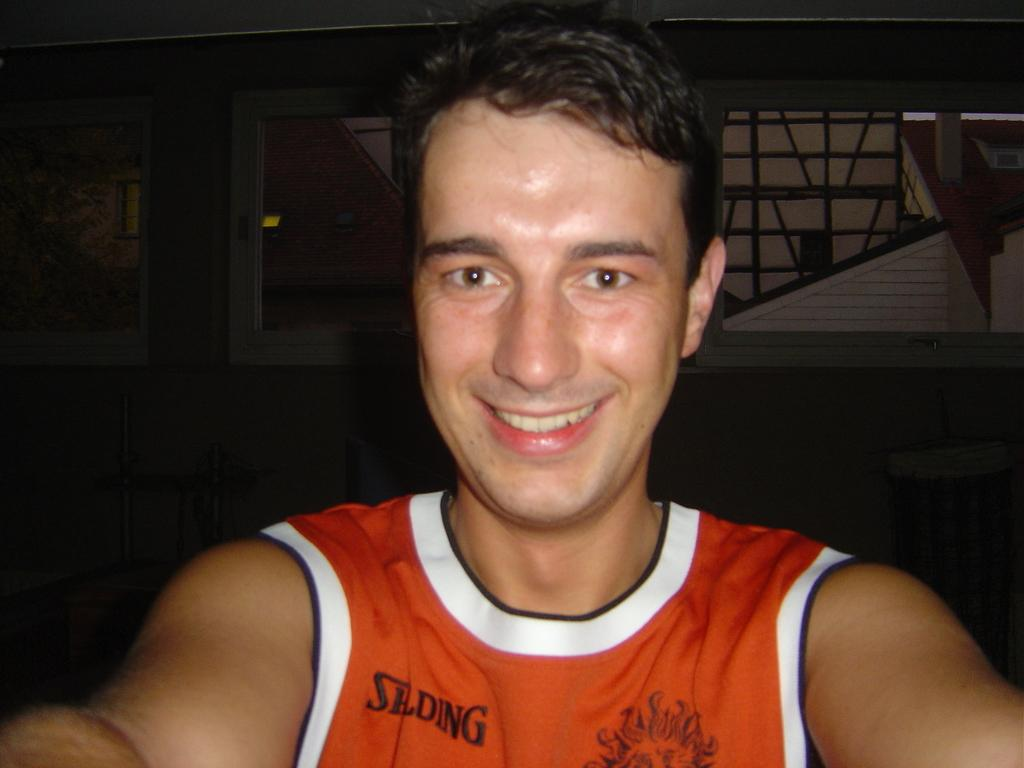<image>
Summarize the visual content of the image. A man in an orange Spalding tank top is taking a selfie. 